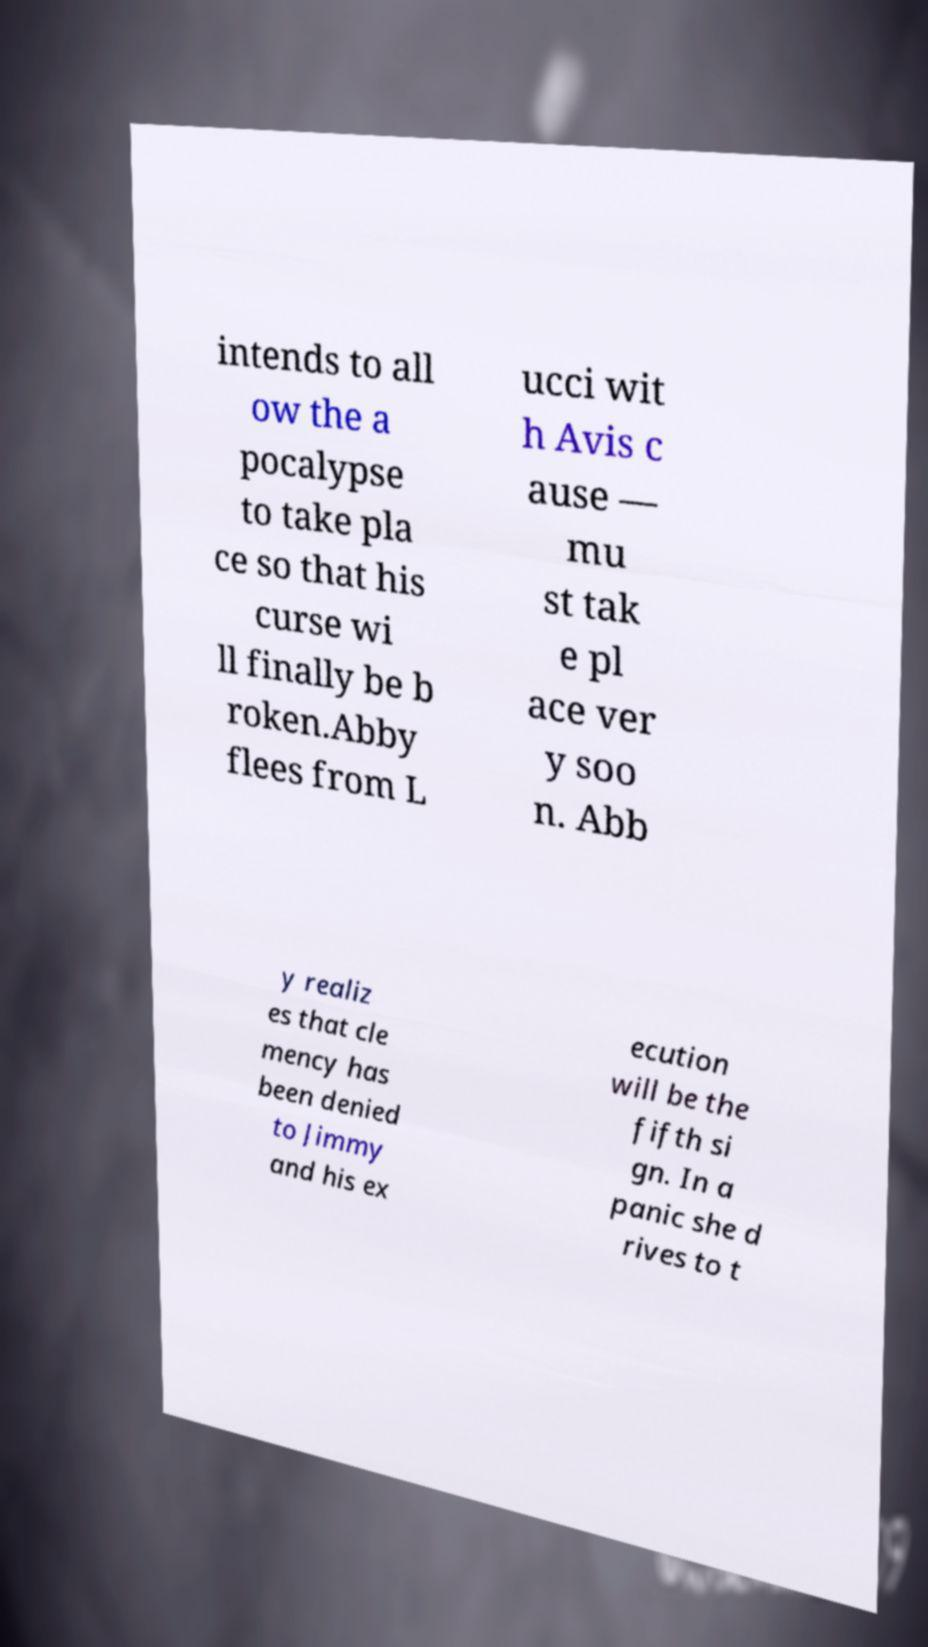Please identify and transcribe the text found in this image. intends to all ow the a pocalypse to take pla ce so that his curse wi ll finally be b roken.Abby flees from L ucci wit h Avis c ause — mu st tak e pl ace ver y soo n. Abb y realiz es that cle mency has been denied to Jimmy and his ex ecution will be the fifth si gn. In a panic she d rives to t 